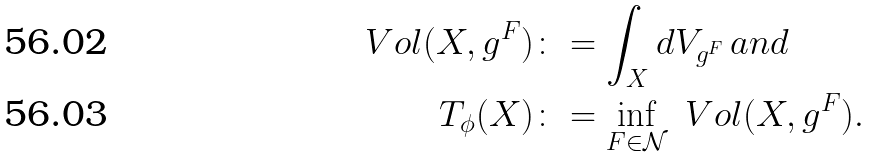<formula> <loc_0><loc_0><loc_500><loc_500>\ V o l ( X , g ^ { F } ) & \colon = \int _ { X } d V _ { g ^ { F } } \, a n d \\ T _ { \phi } ( X ) & \colon = \inf _ { F \in \mathcal { N } } \ V o l ( X , g ^ { F } ) .</formula> 